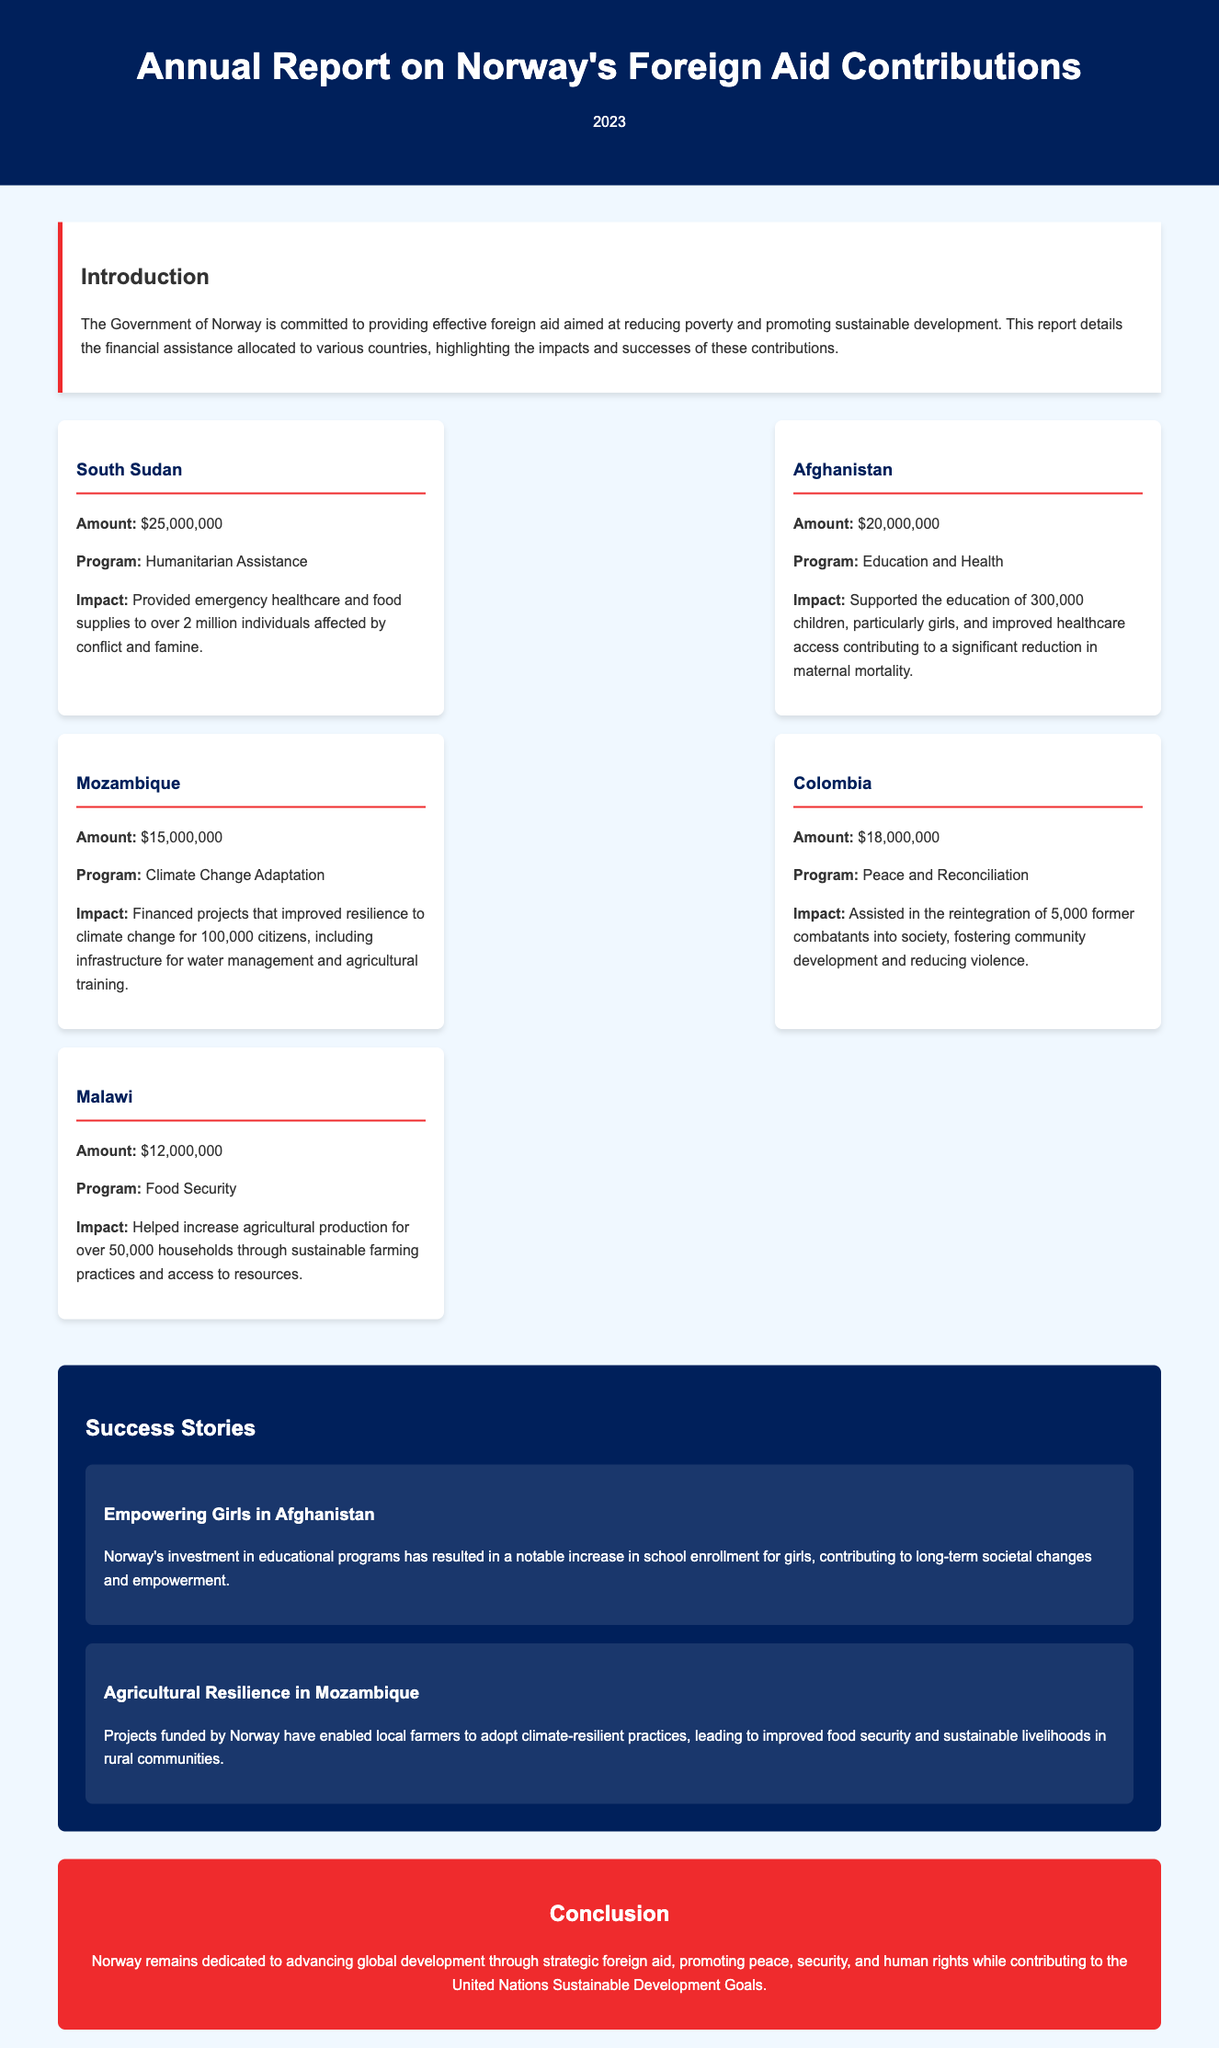what was the amount allocated to South Sudan? The report states that $25,000,000 was allocated to South Sudan as financial assistance.
Answer: $25,000,000 which program received funding in Afghanistan? The document indicates that the education and health program received funding in Afghanistan.
Answer: Education and Health how many children were supported by Norway's aid in Afghanistan? The report mentions that Norway's aid supported the education of 300,000 children in Afghanistan.
Answer: 300,000 what is the main focus of the financial assistance to Mozambique? According to the document, the financial assistance to Mozambique focuses on climate change adaptation.
Answer: Climate Change Adaptation how many former combatants were assisted in Colombia? The report highlights that Norway assisted in the reintegration of 5,000 former combatants in Colombia.
Answer: 5,000 what impact did Norway's investment have on girls' education in Afghanistan? The document explains that Norway's investment resulted in increased school enrollment for girls in Afghanistan.
Answer: Increased school enrollment what conclusion is drawn about Norway's foreign aid contributions? The document concludes that Norway is dedicated to advancing global development through strategic foreign aid.
Answer: Advancing global development which country received the least amount of financial assistance? The report indicates that Malawi received the least amount of financial assistance at $12,000,000.
Answer: $12,000,000 